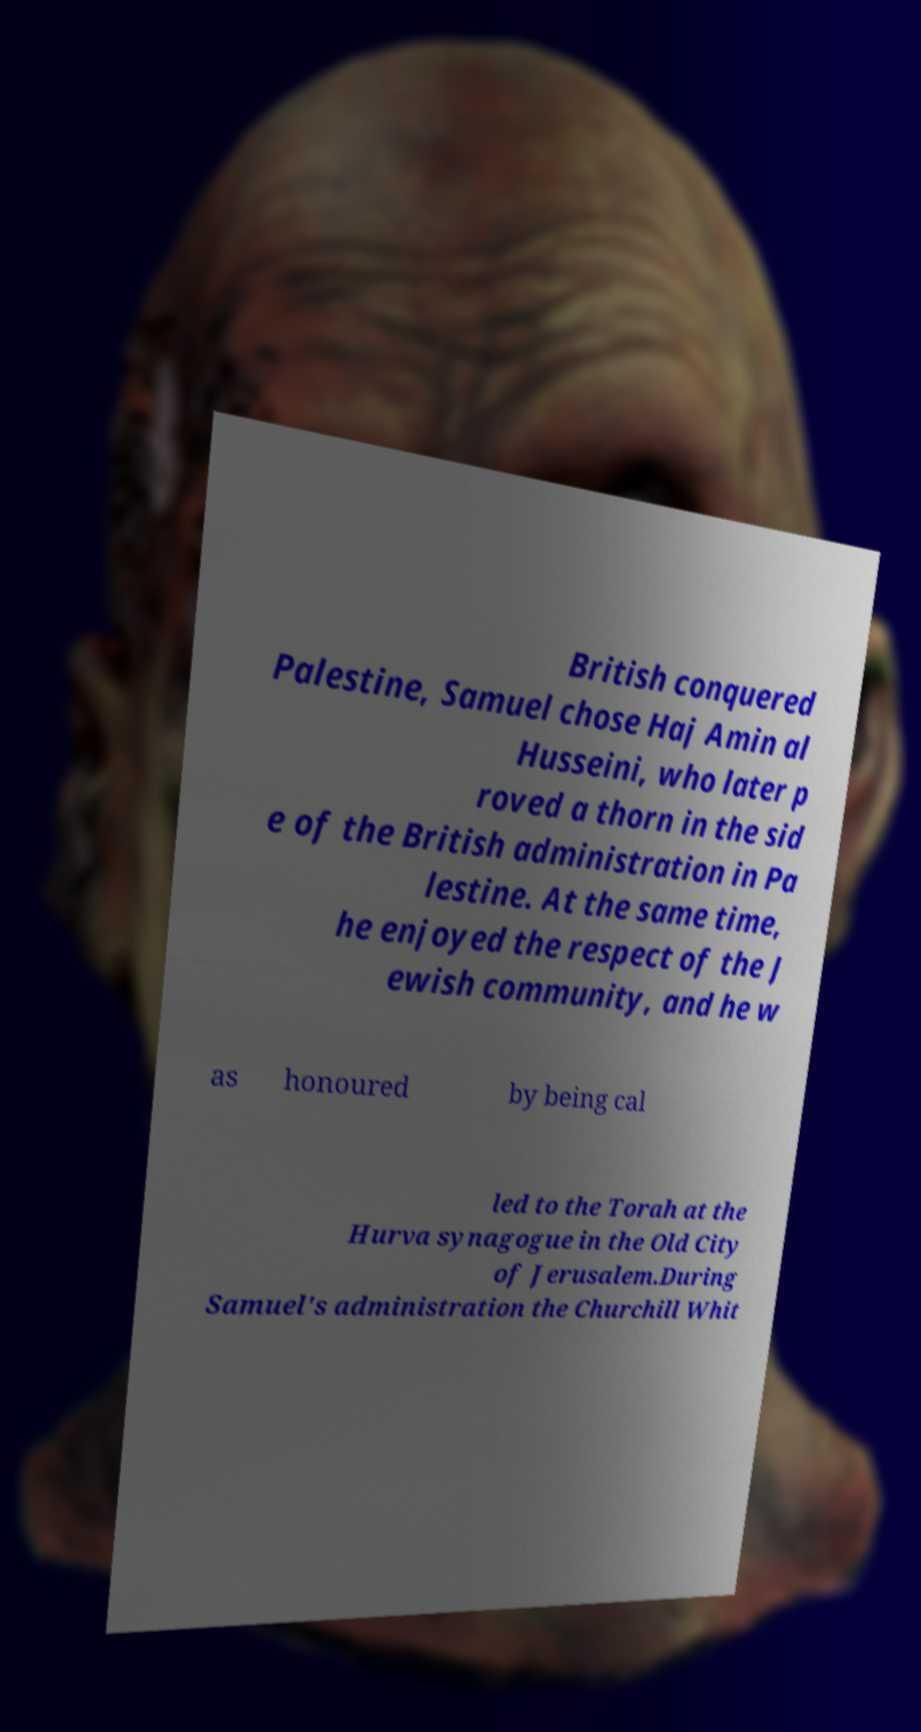There's text embedded in this image that I need extracted. Can you transcribe it verbatim? British conquered Palestine, Samuel chose Haj Amin al Husseini, who later p roved a thorn in the sid e of the British administration in Pa lestine. At the same time, he enjoyed the respect of the J ewish community, and he w as honoured by being cal led to the Torah at the Hurva synagogue in the Old City of Jerusalem.During Samuel's administration the Churchill Whit 